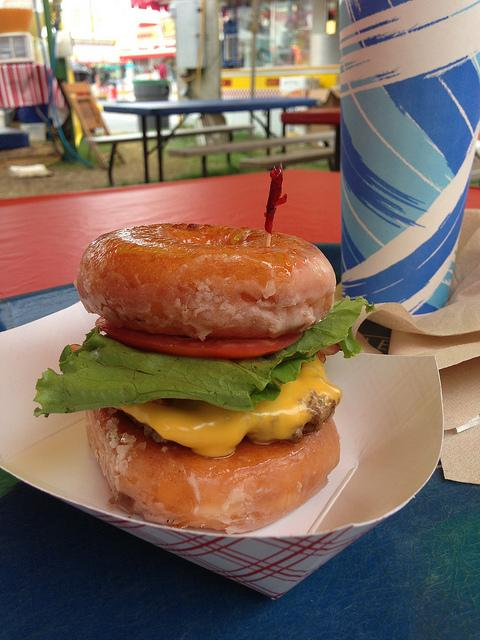What is the most unhealthy part of this cheeseburger?

Choices:
A) donut bun
B) lettuce
C) beef
D) cheese donut bun 